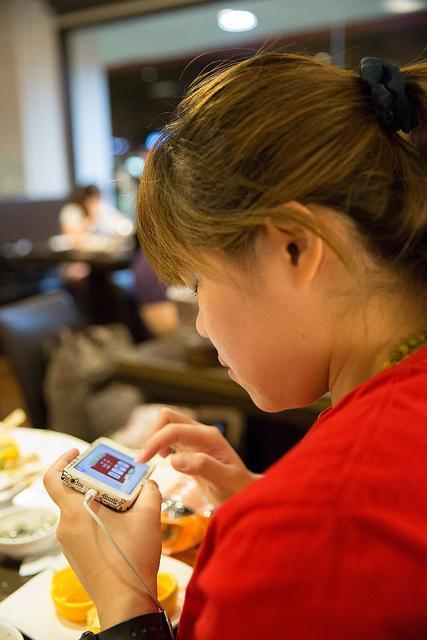How many people are there?
Give a very brief answer. 2. How many chairs are in the picture?
Give a very brief answer. 2. 